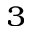<formula> <loc_0><loc_0><loc_500><loc_500>_ { 3 }</formula> 